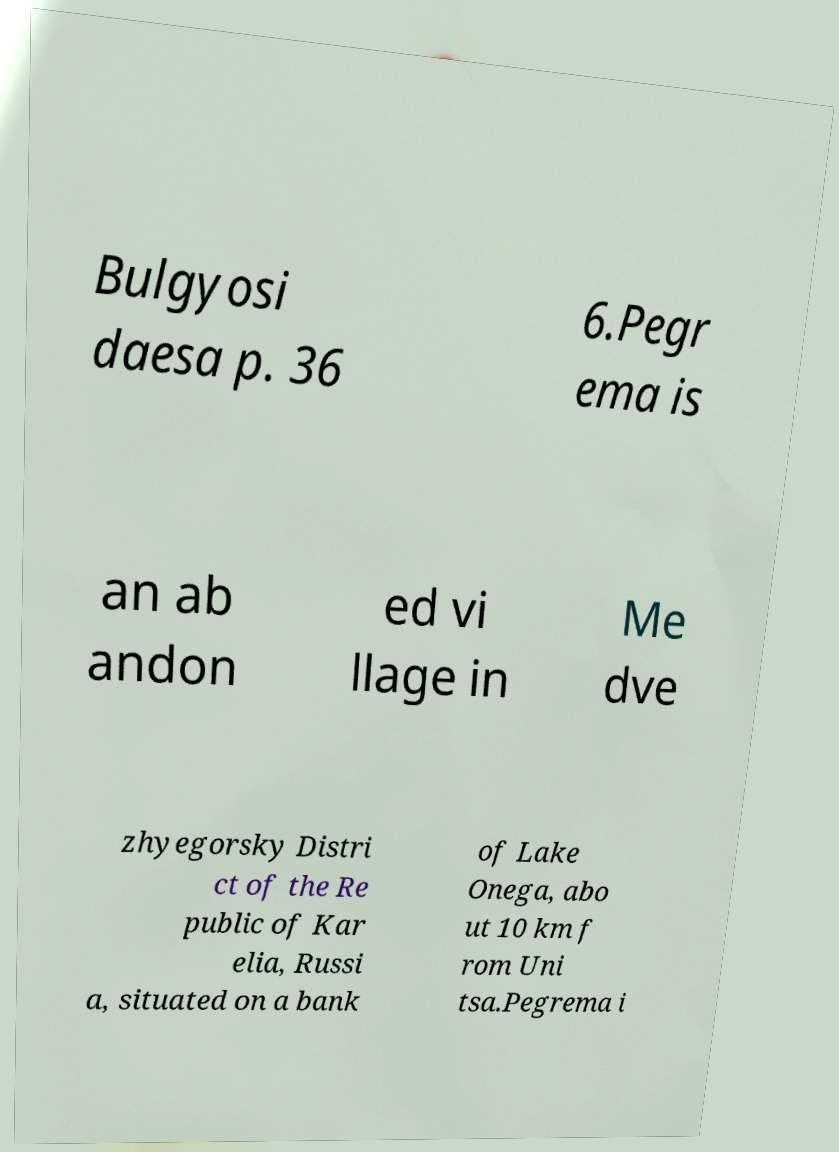There's text embedded in this image that I need extracted. Can you transcribe it verbatim? Bulgyosi daesa p. 36 6.Pegr ema is an ab andon ed vi llage in Me dve zhyegorsky Distri ct of the Re public of Kar elia, Russi a, situated on a bank of Lake Onega, abo ut 10 km f rom Uni tsa.Pegrema i 